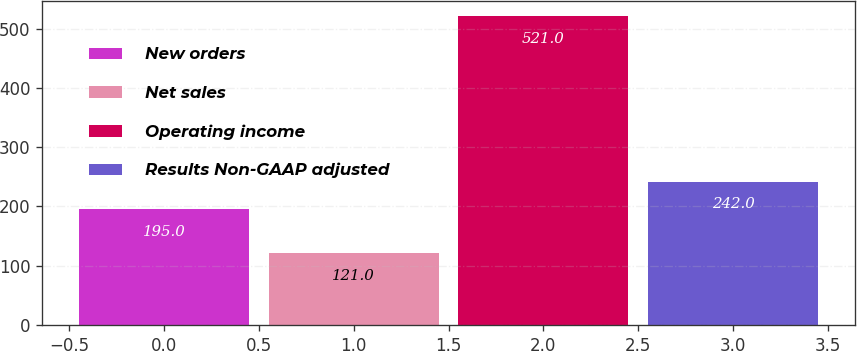Convert chart. <chart><loc_0><loc_0><loc_500><loc_500><bar_chart><fcel>New orders<fcel>Net sales<fcel>Operating income<fcel>Results Non-GAAP adjusted<nl><fcel>195<fcel>121<fcel>521<fcel>242<nl></chart> 